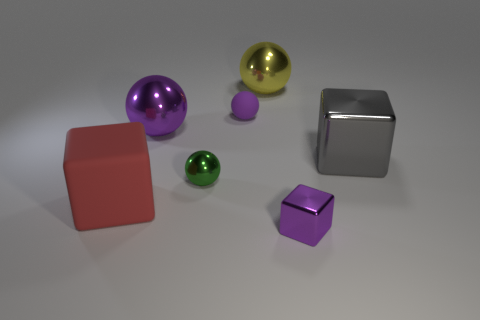Subtract all metallic cubes. How many cubes are left? 1 Subtract all yellow balls. How many balls are left? 3 Add 1 large purple metallic spheres. How many objects exist? 8 Subtract all spheres. How many objects are left? 3 Subtract all yellow blocks. Subtract all cyan balls. How many blocks are left? 3 Subtract all red cylinders. How many purple cubes are left? 1 Subtract all purple spheres. Subtract all small blue matte cubes. How many objects are left? 5 Add 4 big purple metallic objects. How many big purple metallic objects are left? 5 Add 3 gray objects. How many gray objects exist? 4 Subtract 0 red cylinders. How many objects are left? 7 